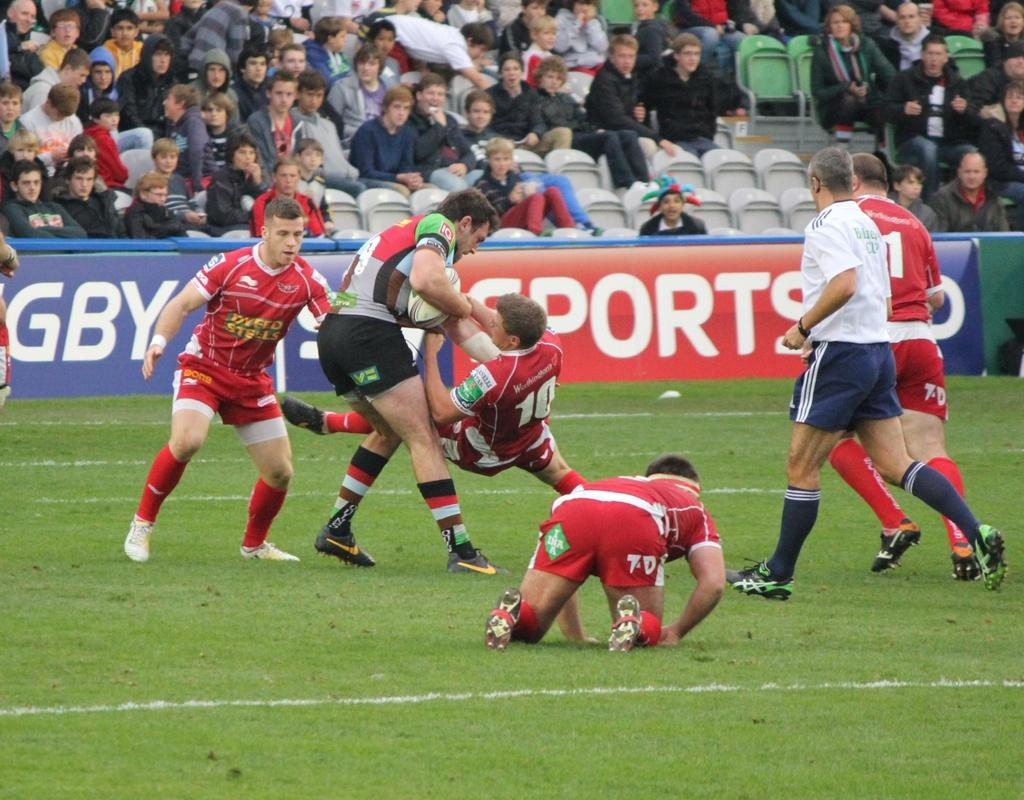Provide a one-sentence caption for the provided image. Several rugby players, including some wearing red jerseys that say Dyfed Steel, are on the field. 